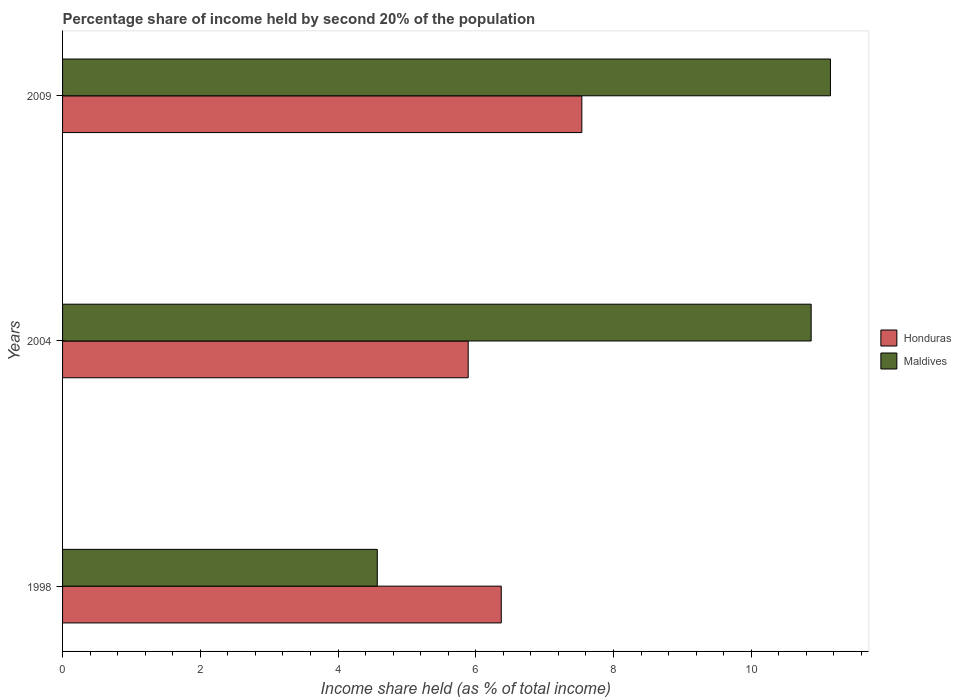How many different coloured bars are there?
Your response must be concise. 2. How many groups of bars are there?
Ensure brevity in your answer.  3. Are the number of bars on each tick of the Y-axis equal?
Make the answer very short. Yes. In how many cases, is the number of bars for a given year not equal to the number of legend labels?
Provide a succinct answer. 0. What is the share of income held by second 20% of the population in Maldives in 2009?
Offer a terse response. 11.15. Across all years, what is the maximum share of income held by second 20% of the population in Honduras?
Offer a very short reply. 7.54. Across all years, what is the minimum share of income held by second 20% of the population in Maldives?
Offer a terse response. 4.57. In which year was the share of income held by second 20% of the population in Honduras maximum?
Offer a very short reply. 2009. What is the total share of income held by second 20% of the population in Honduras in the graph?
Provide a short and direct response. 19.8. What is the difference between the share of income held by second 20% of the population in Maldives in 1998 and that in 2004?
Ensure brevity in your answer.  -6.3. What is the difference between the share of income held by second 20% of the population in Honduras in 2004 and the share of income held by second 20% of the population in Maldives in 1998?
Make the answer very short. 1.32. What is the average share of income held by second 20% of the population in Maldives per year?
Your response must be concise. 8.86. In the year 2004, what is the difference between the share of income held by second 20% of the population in Maldives and share of income held by second 20% of the population in Honduras?
Provide a short and direct response. 4.98. In how many years, is the share of income held by second 20% of the population in Honduras greater than 9.6 %?
Make the answer very short. 0. What is the ratio of the share of income held by second 20% of the population in Maldives in 1998 to that in 2004?
Your response must be concise. 0.42. What is the difference between the highest and the second highest share of income held by second 20% of the population in Maldives?
Offer a very short reply. 0.28. What is the difference between the highest and the lowest share of income held by second 20% of the population in Honduras?
Keep it short and to the point. 1.65. In how many years, is the share of income held by second 20% of the population in Maldives greater than the average share of income held by second 20% of the population in Maldives taken over all years?
Give a very brief answer. 2. What does the 1st bar from the top in 1998 represents?
Your answer should be very brief. Maldives. What does the 2nd bar from the bottom in 2009 represents?
Offer a very short reply. Maldives. Are all the bars in the graph horizontal?
Provide a short and direct response. Yes. How many years are there in the graph?
Provide a short and direct response. 3. What is the difference between two consecutive major ticks on the X-axis?
Provide a succinct answer. 2. Does the graph contain grids?
Ensure brevity in your answer.  No. Where does the legend appear in the graph?
Ensure brevity in your answer.  Center right. What is the title of the graph?
Your answer should be compact. Percentage share of income held by second 20% of the population. Does "Bolivia" appear as one of the legend labels in the graph?
Offer a terse response. No. What is the label or title of the X-axis?
Ensure brevity in your answer.  Income share held (as % of total income). What is the label or title of the Y-axis?
Your response must be concise. Years. What is the Income share held (as % of total income) of Honduras in 1998?
Your answer should be compact. 6.37. What is the Income share held (as % of total income) of Maldives in 1998?
Offer a terse response. 4.57. What is the Income share held (as % of total income) of Honduras in 2004?
Your response must be concise. 5.89. What is the Income share held (as % of total income) in Maldives in 2004?
Provide a short and direct response. 10.87. What is the Income share held (as % of total income) in Honduras in 2009?
Ensure brevity in your answer.  7.54. What is the Income share held (as % of total income) of Maldives in 2009?
Give a very brief answer. 11.15. Across all years, what is the maximum Income share held (as % of total income) in Honduras?
Give a very brief answer. 7.54. Across all years, what is the maximum Income share held (as % of total income) of Maldives?
Keep it short and to the point. 11.15. Across all years, what is the minimum Income share held (as % of total income) of Honduras?
Offer a very short reply. 5.89. Across all years, what is the minimum Income share held (as % of total income) of Maldives?
Offer a very short reply. 4.57. What is the total Income share held (as % of total income) of Honduras in the graph?
Ensure brevity in your answer.  19.8. What is the total Income share held (as % of total income) in Maldives in the graph?
Make the answer very short. 26.59. What is the difference between the Income share held (as % of total income) of Honduras in 1998 and that in 2004?
Give a very brief answer. 0.48. What is the difference between the Income share held (as % of total income) in Honduras in 1998 and that in 2009?
Make the answer very short. -1.17. What is the difference between the Income share held (as % of total income) of Maldives in 1998 and that in 2009?
Give a very brief answer. -6.58. What is the difference between the Income share held (as % of total income) of Honduras in 2004 and that in 2009?
Offer a very short reply. -1.65. What is the difference between the Income share held (as % of total income) in Maldives in 2004 and that in 2009?
Keep it short and to the point. -0.28. What is the difference between the Income share held (as % of total income) in Honduras in 1998 and the Income share held (as % of total income) in Maldives in 2009?
Offer a very short reply. -4.78. What is the difference between the Income share held (as % of total income) of Honduras in 2004 and the Income share held (as % of total income) of Maldives in 2009?
Provide a short and direct response. -5.26. What is the average Income share held (as % of total income) in Honduras per year?
Give a very brief answer. 6.6. What is the average Income share held (as % of total income) in Maldives per year?
Keep it short and to the point. 8.86. In the year 1998, what is the difference between the Income share held (as % of total income) of Honduras and Income share held (as % of total income) of Maldives?
Provide a succinct answer. 1.8. In the year 2004, what is the difference between the Income share held (as % of total income) of Honduras and Income share held (as % of total income) of Maldives?
Ensure brevity in your answer.  -4.98. In the year 2009, what is the difference between the Income share held (as % of total income) in Honduras and Income share held (as % of total income) in Maldives?
Give a very brief answer. -3.61. What is the ratio of the Income share held (as % of total income) of Honduras in 1998 to that in 2004?
Give a very brief answer. 1.08. What is the ratio of the Income share held (as % of total income) of Maldives in 1998 to that in 2004?
Your answer should be very brief. 0.42. What is the ratio of the Income share held (as % of total income) of Honduras in 1998 to that in 2009?
Offer a very short reply. 0.84. What is the ratio of the Income share held (as % of total income) of Maldives in 1998 to that in 2009?
Ensure brevity in your answer.  0.41. What is the ratio of the Income share held (as % of total income) of Honduras in 2004 to that in 2009?
Provide a short and direct response. 0.78. What is the ratio of the Income share held (as % of total income) of Maldives in 2004 to that in 2009?
Provide a short and direct response. 0.97. What is the difference between the highest and the second highest Income share held (as % of total income) of Honduras?
Offer a terse response. 1.17. What is the difference between the highest and the second highest Income share held (as % of total income) in Maldives?
Ensure brevity in your answer.  0.28. What is the difference between the highest and the lowest Income share held (as % of total income) in Honduras?
Offer a terse response. 1.65. What is the difference between the highest and the lowest Income share held (as % of total income) in Maldives?
Provide a succinct answer. 6.58. 